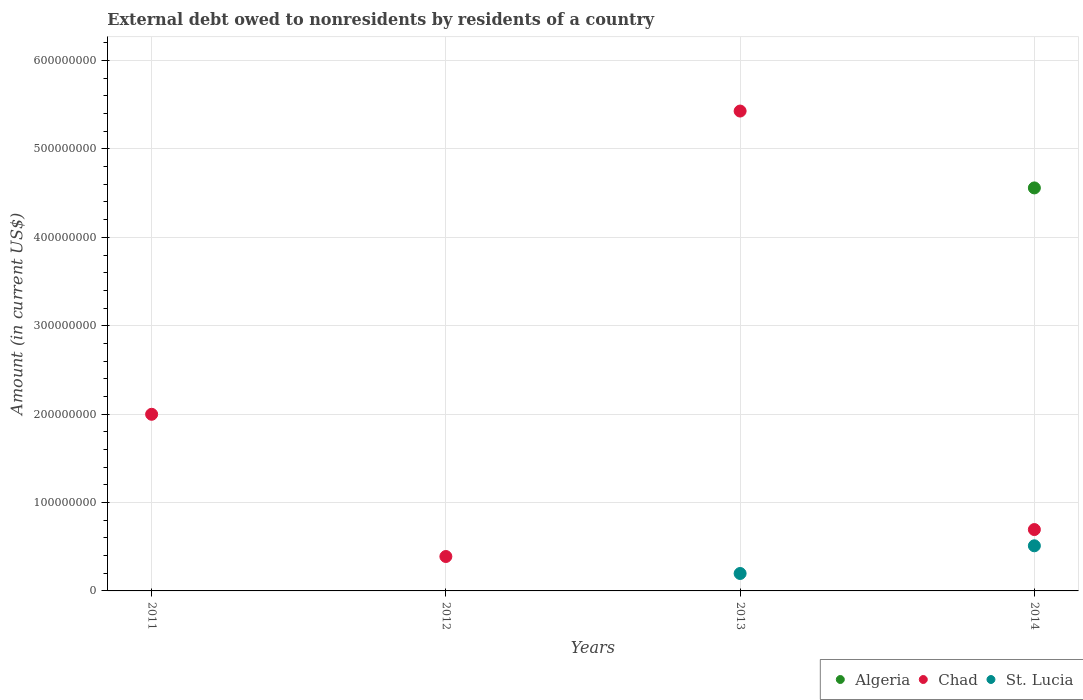How many different coloured dotlines are there?
Ensure brevity in your answer.  3. Is the number of dotlines equal to the number of legend labels?
Your answer should be compact. No. What is the external debt owed by residents in Chad in 2014?
Keep it short and to the point. 6.94e+07. Across all years, what is the maximum external debt owed by residents in Algeria?
Offer a very short reply. 4.56e+08. Across all years, what is the minimum external debt owed by residents in St. Lucia?
Your answer should be compact. 0. What is the total external debt owed by residents in Chad in the graph?
Offer a terse response. 8.51e+08. What is the difference between the external debt owed by residents in Chad in 2012 and that in 2014?
Offer a terse response. -3.05e+07. What is the difference between the external debt owed by residents in Algeria in 2013 and the external debt owed by residents in St. Lucia in 2012?
Provide a short and direct response. 0. What is the average external debt owed by residents in Chad per year?
Give a very brief answer. 2.13e+08. In the year 2014, what is the difference between the external debt owed by residents in St. Lucia and external debt owed by residents in Algeria?
Ensure brevity in your answer.  -4.05e+08. In how many years, is the external debt owed by residents in Chad greater than 580000000 US$?
Give a very brief answer. 0. What is the ratio of the external debt owed by residents in Chad in 2013 to that in 2014?
Give a very brief answer. 7.82. Is the external debt owed by residents in Chad in 2011 less than that in 2013?
Your answer should be very brief. Yes. What is the difference between the highest and the second highest external debt owed by residents in Chad?
Keep it short and to the point. 3.43e+08. What is the difference between the highest and the lowest external debt owed by residents in St. Lucia?
Give a very brief answer. 5.11e+07. In how many years, is the external debt owed by residents in Algeria greater than the average external debt owed by residents in Algeria taken over all years?
Provide a short and direct response. 1. Is it the case that in every year, the sum of the external debt owed by residents in Algeria and external debt owed by residents in Chad  is greater than the external debt owed by residents in St. Lucia?
Your answer should be very brief. Yes. Does the external debt owed by residents in Algeria monotonically increase over the years?
Your answer should be very brief. Yes. How many dotlines are there?
Offer a terse response. 3. How many years are there in the graph?
Keep it short and to the point. 4. What is the difference between two consecutive major ticks on the Y-axis?
Provide a short and direct response. 1.00e+08. How many legend labels are there?
Offer a very short reply. 3. What is the title of the graph?
Give a very brief answer. External debt owed to nonresidents by residents of a country. Does "Albania" appear as one of the legend labels in the graph?
Provide a succinct answer. No. What is the label or title of the X-axis?
Your response must be concise. Years. What is the Amount (in current US$) of Algeria in 2011?
Provide a short and direct response. 0. What is the Amount (in current US$) in Chad in 2011?
Keep it short and to the point. 2.00e+08. What is the Amount (in current US$) of Algeria in 2012?
Provide a short and direct response. 0. What is the Amount (in current US$) of Chad in 2012?
Provide a short and direct response. 3.89e+07. What is the Amount (in current US$) in St. Lucia in 2012?
Your answer should be very brief. 0. What is the Amount (in current US$) in Algeria in 2013?
Give a very brief answer. 0. What is the Amount (in current US$) in Chad in 2013?
Provide a short and direct response. 5.43e+08. What is the Amount (in current US$) of St. Lucia in 2013?
Ensure brevity in your answer.  1.97e+07. What is the Amount (in current US$) in Algeria in 2014?
Keep it short and to the point. 4.56e+08. What is the Amount (in current US$) in Chad in 2014?
Give a very brief answer. 6.94e+07. What is the Amount (in current US$) of St. Lucia in 2014?
Offer a very short reply. 5.11e+07. Across all years, what is the maximum Amount (in current US$) of Algeria?
Provide a succinct answer. 4.56e+08. Across all years, what is the maximum Amount (in current US$) of Chad?
Keep it short and to the point. 5.43e+08. Across all years, what is the maximum Amount (in current US$) of St. Lucia?
Make the answer very short. 5.11e+07. Across all years, what is the minimum Amount (in current US$) in Algeria?
Provide a succinct answer. 0. Across all years, what is the minimum Amount (in current US$) in Chad?
Keep it short and to the point. 3.89e+07. What is the total Amount (in current US$) of Algeria in the graph?
Give a very brief answer. 4.56e+08. What is the total Amount (in current US$) in Chad in the graph?
Keep it short and to the point. 8.51e+08. What is the total Amount (in current US$) in St. Lucia in the graph?
Your answer should be very brief. 7.08e+07. What is the difference between the Amount (in current US$) in Chad in 2011 and that in 2012?
Offer a terse response. 1.61e+08. What is the difference between the Amount (in current US$) of Chad in 2011 and that in 2013?
Provide a succinct answer. -3.43e+08. What is the difference between the Amount (in current US$) in Chad in 2011 and that in 2014?
Provide a short and direct response. 1.30e+08. What is the difference between the Amount (in current US$) in Chad in 2012 and that in 2013?
Your answer should be compact. -5.04e+08. What is the difference between the Amount (in current US$) in Chad in 2012 and that in 2014?
Your answer should be compact. -3.05e+07. What is the difference between the Amount (in current US$) of Chad in 2013 and that in 2014?
Your answer should be compact. 4.73e+08. What is the difference between the Amount (in current US$) of St. Lucia in 2013 and that in 2014?
Give a very brief answer. -3.13e+07. What is the difference between the Amount (in current US$) of Chad in 2011 and the Amount (in current US$) of St. Lucia in 2013?
Your response must be concise. 1.80e+08. What is the difference between the Amount (in current US$) of Chad in 2011 and the Amount (in current US$) of St. Lucia in 2014?
Make the answer very short. 1.49e+08. What is the difference between the Amount (in current US$) of Chad in 2012 and the Amount (in current US$) of St. Lucia in 2013?
Your answer should be very brief. 1.92e+07. What is the difference between the Amount (in current US$) in Chad in 2012 and the Amount (in current US$) in St. Lucia in 2014?
Offer a very short reply. -1.21e+07. What is the difference between the Amount (in current US$) of Chad in 2013 and the Amount (in current US$) of St. Lucia in 2014?
Offer a very short reply. 4.92e+08. What is the average Amount (in current US$) in Algeria per year?
Keep it short and to the point. 1.14e+08. What is the average Amount (in current US$) of Chad per year?
Ensure brevity in your answer.  2.13e+08. What is the average Amount (in current US$) in St. Lucia per year?
Provide a succinct answer. 1.77e+07. In the year 2013, what is the difference between the Amount (in current US$) of Chad and Amount (in current US$) of St. Lucia?
Your response must be concise. 5.23e+08. In the year 2014, what is the difference between the Amount (in current US$) in Algeria and Amount (in current US$) in Chad?
Your answer should be very brief. 3.86e+08. In the year 2014, what is the difference between the Amount (in current US$) in Algeria and Amount (in current US$) in St. Lucia?
Give a very brief answer. 4.05e+08. In the year 2014, what is the difference between the Amount (in current US$) in Chad and Amount (in current US$) in St. Lucia?
Ensure brevity in your answer.  1.84e+07. What is the ratio of the Amount (in current US$) in Chad in 2011 to that in 2012?
Keep it short and to the point. 5.13. What is the ratio of the Amount (in current US$) of Chad in 2011 to that in 2013?
Give a very brief answer. 0.37. What is the ratio of the Amount (in current US$) in Chad in 2011 to that in 2014?
Provide a short and direct response. 2.88. What is the ratio of the Amount (in current US$) in Chad in 2012 to that in 2013?
Provide a short and direct response. 0.07. What is the ratio of the Amount (in current US$) of Chad in 2012 to that in 2014?
Make the answer very short. 0.56. What is the ratio of the Amount (in current US$) of Chad in 2013 to that in 2014?
Keep it short and to the point. 7.82. What is the ratio of the Amount (in current US$) in St. Lucia in 2013 to that in 2014?
Ensure brevity in your answer.  0.39. What is the difference between the highest and the second highest Amount (in current US$) in Chad?
Your answer should be compact. 3.43e+08. What is the difference between the highest and the lowest Amount (in current US$) of Algeria?
Ensure brevity in your answer.  4.56e+08. What is the difference between the highest and the lowest Amount (in current US$) of Chad?
Your answer should be compact. 5.04e+08. What is the difference between the highest and the lowest Amount (in current US$) in St. Lucia?
Give a very brief answer. 5.11e+07. 